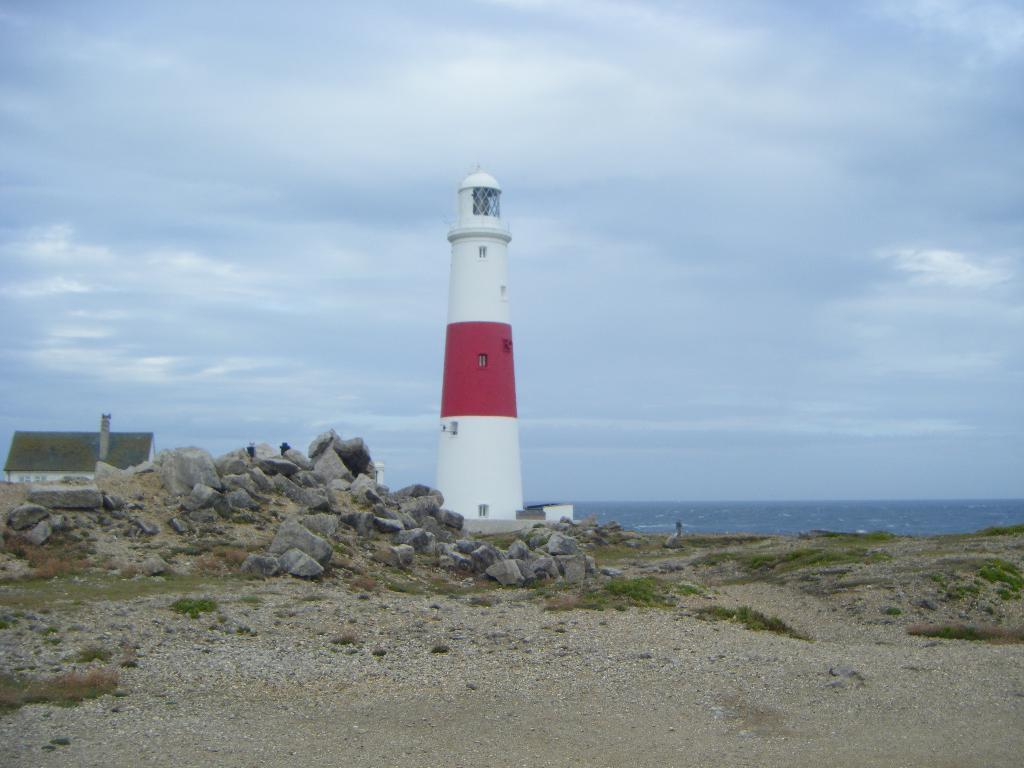What type of vegetation can be seen in the image? There is green grass in the image. What other objects are present in the image? There are rocks, a lighthouse, and a house in the image. What can be seen in the background of the image? Water and the sky are visible in the background of the image. Can you hear the field laughing in the image? There is no field present in the image, and fields do not have the ability to laugh. 